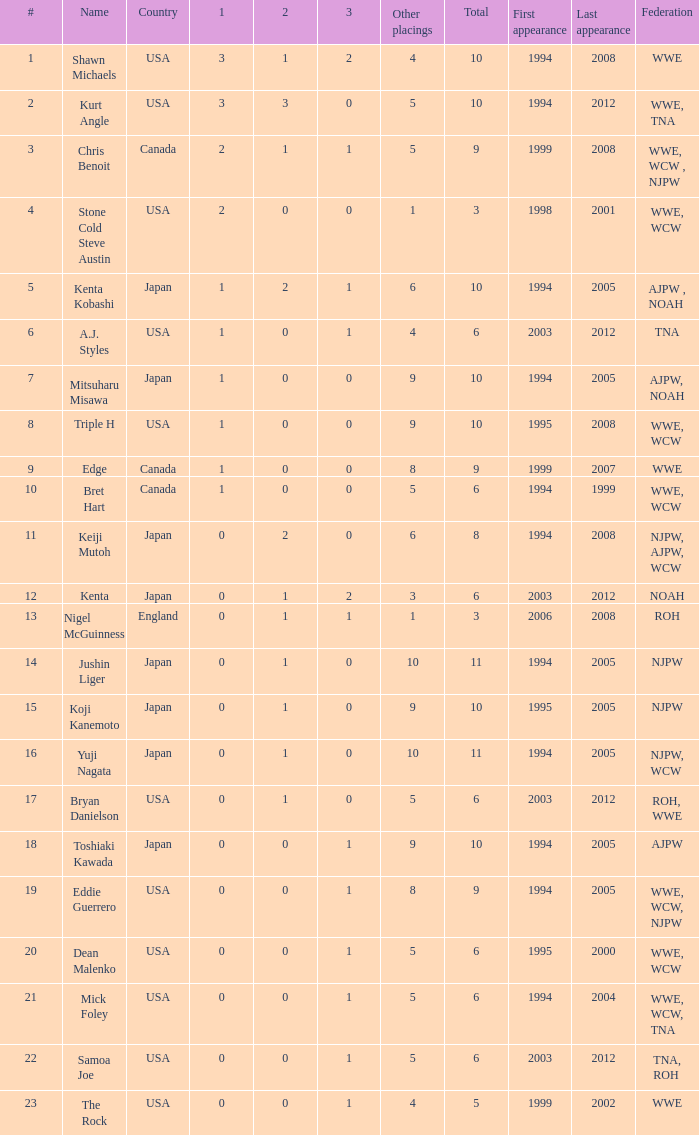How many instances has a wrestler from the nation of england competed in this event? 1.0. 